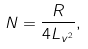<formula> <loc_0><loc_0><loc_500><loc_500>N = \frac { R } { 4 L _ { v ^ { 2 } } } ,</formula> 